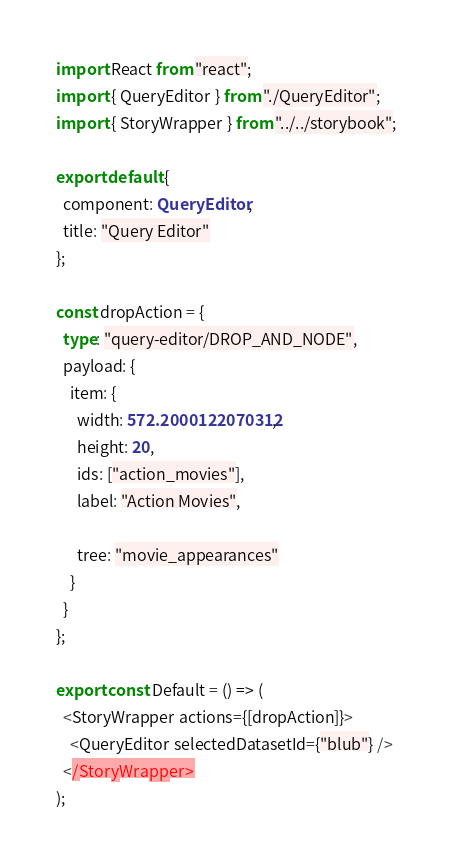<code> <loc_0><loc_0><loc_500><loc_500><_TypeScript_>import React from "react";
import { QueryEditor } from "./QueryEditor";
import { StoryWrapper } from "../../storybook";

export default {
  component: QueryEditor,
  title: "Query Editor"
};

const dropAction = {
  type: "query-editor/DROP_AND_NODE",
  payload: {
    item: {
      width: 572.2000122070312,
      height: 20,
      ids: ["action_movies"],
      label: "Action Movies",

      tree: "movie_appearances"
    }
  }
};

export const Default = () => (
  <StoryWrapper actions={[dropAction]}>
    <QueryEditor selectedDatasetId={"blub"} />
  </StoryWrapper>
);
</code> 